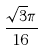<formula> <loc_0><loc_0><loc_500><loc_500>\frac { \sqrt { 3 } \pi } { 1 6 }</formula> 